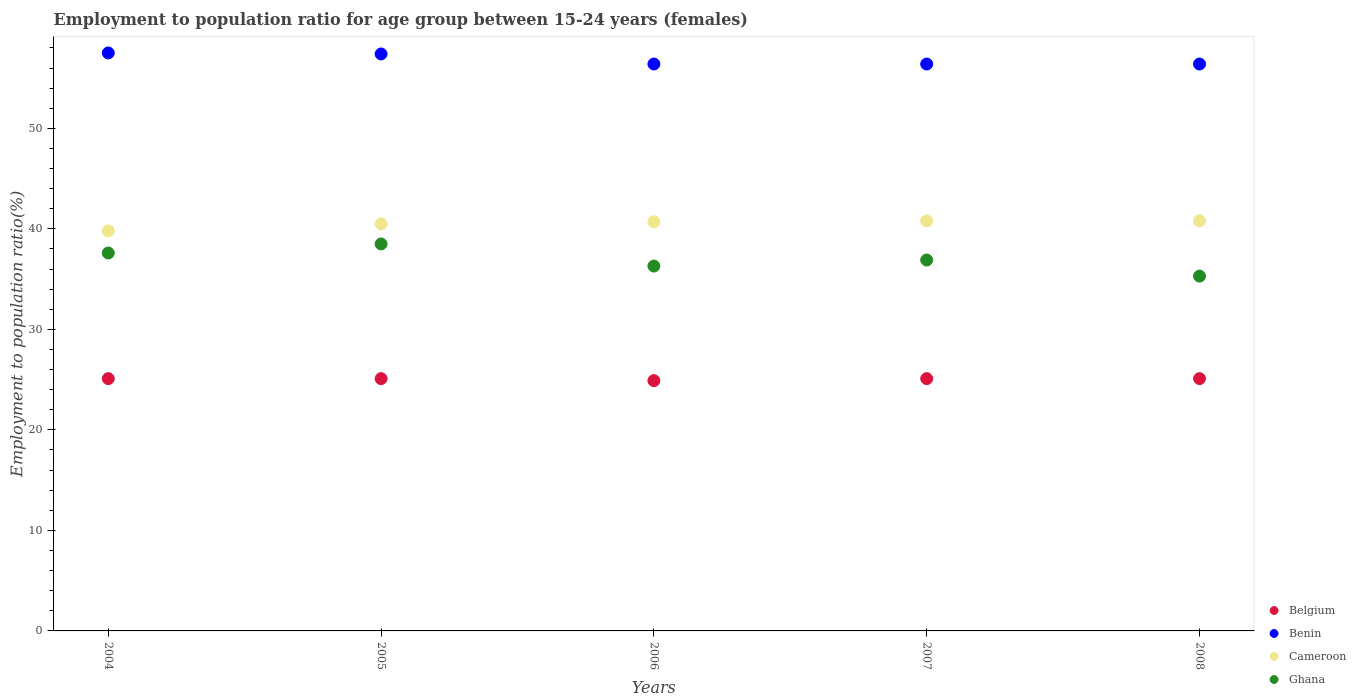Is the number of dotlines equal to the number of legend labels?
Offer a terse response. Yes. What is the employment to population ratio in Belgium in 2005?
Offer a terse response. 25.1. Across all years, what is the maximum employment to population ratio in Ghana?
Provide a short and direct response. 38.5. Across all years, what is the minimum employment to population ratio in Cameroon?
Your answer should be very brief. 39.8. In which year was the employment to population ratio in Belgium maximum?
Your response must be concise. 2004. What is the total employment to population ratio in Benin in the graph?
Your answer should be compact. 284.1. What is the difference between the employment to population ratio in Benin in 2004 and that in 2007?
Offer a very short reply. 1.1. What is the average employment to population ratio in Belgium per year?
Give a very brief answer. 25.06. In the year 2005, what is the difference between the employment to population ratio in Ghana and employment to population ratio in Belgium?
Your answer should be compact. 13.4. In how many years, is the employment to population ratio in Cameroon greater than 24 %?
Give a very brief answer. 5. What is the ratio of the employment to population ratio in Cameroon in 2004 to that in 2005?
Give a very brief answer. 0.98. Is the difference between the employment to population ratio in Ghana in 2004 and 2008 greater than the difference between the employment to population ratio in Belgium in 2004 and 2008?
Offer a terse response. Yes. What is the difference between the highest and the second highest employment to population ratio in Ghana?
Keep it short and to the point. 0.9. What is the difference between the highest and the lowest employment to population ratio in Benin?
Offer a very short reply. 1.1. Is the sum of the employment to population ratio in Ghana in 2004 and 2008 greater than the maximum employment to population ratio in Benin across all years?
Your answer should be very brief. Yes. Is it the case that in every year, the sum of the employment to population ratio in Benin and employment to population ratio in Ghana  is greater than the sum of employment to population ratio in Belgium and employment to population ratio in Cameroon?
Provide a short and direct response. Yes. Does the employment to population ratio in Cameroon monotonically increase over the years?
Ensure brevity in your answer.  No. How many years are there in the graph?
Offer a terse response. 5. What is the difference between two consecutive major ticks on the Y-axis?
Make the answer very short. 10. Does the graph contain any zero values?
Your answer should be very brief. No. Where does the legend appear in the graph?
Provide a short and direct response. Bottom right. How many legend labels are there?
Offer a very short reply. 4. How are the legend labels stacked?
Make the answer very short. Vertical. What is the title of the graph?
Your answer should be very brief. Employment to population ratio for age group between 15-24 years (females). Does "Myanmar" appear as one of the legend labels in the graph?
Make the answer very short. No. What is the Employment to population ratio(%) of Belgium in 2004?
Offer a terse response. 25.1. What is the Employment to population ratio(%) of Benin in 2004?
Make the answer very short. 57.5. What is the Employment to population ratio(%) of Cameroon in 2004?
Offer a very short reply. 39.8. What is the Employment to population ratio(%) in Ghana in 2004?
Give a very brief answer. 37.6. What is the Employment to population ratio(%) of Belgium in 2005?
Make the answer very short. 25.1. What is the Employment to population ratio(%) in Benin in 2005?
Provide a short and direct response. 57.4. What is the Employment to population ratio(%) in Cameroon in 2005?
Ensure brevity in your answer.  40.5. What is the Employment to population ratio(%) in Ghana in 2005?
Your answer should be very brief. 38.5. What is the Employment to population ratio(%) in Belgium in 2006?
Offer a very short reply. 24.9. What is the Employment to population ratio(%) in Benin in 2006?
Offer a very short reply. 56.4. What is the Employment to population ratio(%) in Cameroon in 2006?
Ensure brevity in your answer.  40.7. What is the Employment to population ratio(%) in Ghana in 2006?
Offer a terse response. 36.3. What is the Employment to population ratio(%) in Belgium in 2007?
Offer a terse response. 25.1. What is the Employment to population ratio(%) of Benin in 2007?
Your response must be concise. 56.4. What is the Employment to population ratio(%) of Cameroon in 2007?
Give a very brief answer. 40.8. What is the Employment to population ratio(%) in Ghana in 2007?
Your answer should be compact. 36.9. What is the Employment to population ratio(%) of Belgium in 2008?
Your answer should be very brief. 25.1. What is the Employment to population ratio(%) of Benin in 2008?
Your response must be concise. 56.4. What is the Employment to population ratio(%) of Cameroon in 2008?
Provide a short and direct response. 40.8. What is the Employment to population ratio(%) in Ghana in 2008?
Your answer should be compact. 35.3. Across all years, what is the maximum Employment to population ratio(%) of Belgium?
Keep it short and to the point. 25.1. Across all years, what is the maximum Employment to population ratio(%) in Benin?
Your answer should be compact. 57.5. Across all years, what is the maximum Employment to population ratio(%) of Cameroon?
Provide a succinct answer. 40.8. Across all years, what is the maximum Employment to population ratio(%) of Ghana?
Keep it short and to the point. 38.5. Across all years, what is the minimum Employment to population ratio(%) in Belgium?
Give a very brief answer. 24.9. Across all years, what is the minimum Employment to population ratio(%) in Benin?
Your answer should be compact. 56.4. Across all years, what is the minimum Employment to population ratio(%) in Cameroon?
Give a very brief answer. 39.8. Across all years, what is the minimum Employment to population ratio(%) of Ghana?
Keep it short and to the point. 35.3. What is the total Employment to population ratio(%) of Belgium in the graph?
Give a very brief answer. 125.3. What is the total Employment to population ratio(%) of Benin in the graph?
Provide a short and direct response. 284.1. What is the total Employment to population ratio(%) of Cameroon in the graph?
Give a very brief answer. 202.6. What is the total Employment to population ratio(%) in Ghana in the graph?
Offer a terse response. 184.6. What is the difference between the Employment to population ratio(%) of Belgium in 2004 and that in 2005?
Provide a succinct answer. 0. What is the difference between the Employment to population ratio(%) of Benin in 2004 and that in 2005?
Your answer should be very brief. 0.1. What is the difference between the Employment to population ratio(%) in Cameroon in 2004 and that in 2005?
Your answer should be very brief. -0.7. What is the difference between the Employment to population ratio(%) in Ghana in 2004 and that in 2005?
Provide a short and direct response. -0.9. What is the difference between the Employment to population ratio(%) of Ghana in 2004 and that in 2006?
Provide a succinct answer. 1.3. What is the difference between the Employment to population ratio(%) in Ghana in 2004 and that in 2007?
Offer a very short reply. 0.7. What is the difference between the Employment to population ratio(%) in Benin in 2004 and that in 2008?
Provide a short and direct response. 1.1. What is the difference between the Employment to population ratio(%) in Benin in 2005 and that in 2006?
Provide a succinct answer. 1. What is the difference between the Employment to population ratio(%) of Cameroon in 2005 and that in 2006?
Offer a very short reply. -0.2. What is the difference between the Employment to population ratio(%) of Cameroon in 2005 and that in 2007?
Keep it short and to the point. -0.3. What is the difference between the Employment to population ratio(%) in Ghana in 2005 and that in 2007?
Your response must be concise. 1.6. What is the difference between the Employment to population ratio(%) in Belgium in 2005 and that in 2008?
Provide a succinct answer. 0. What is the difference between the Employment to population ratio(%) in Benin in 2005 and that in 2008?
Ensure brevity in your answer.  1. What is the difference between the Employment to population ratio(%) in Cameroon in 2005 and that in 2008?
Make the answer very short. -0.3. What is the difference between the Employment to population ratio(%) in Ghana in 2005 and that in 2008?
Provide a short and direct response. 3.2. What is the difference between the Employment to population ratio(%) in Belgium in 2006 and that in 2007?
Provide a short and direct response. -0.2. What is the difference between the Employment to population ratio(%) of Ghana in 2006 and that in 2007?
Provide a short and direct response. -0.6. What is the difference between the Employment to population ratio(%) of Benin in 2006 and that in 2008?
Provide a succinct answer. 0. What is the difference between the Employment to population ratio(%) of Ghana in 2006 and that in 2008?
Give a very brief answer. 1. What is the difference between the Employment to population ratio(%) in Benin in 2007 and that in 2008?
Your answer should be very brief. 0. What is the difference between the Employment to population ratio(%) in Cameroon in 2007 and that in 2008?
Provide a short and direct response. 0. What is the difference between the Employment to population ratio(%) in Ghana in 2007 and that in 2008?
Provide a succinct answer. 1.6. What is the difference between the Employment to population ratio(%) of Belgium in 2004 and the Employment to population ratio(%) of Benin in 2005?
Make the answer very short. -32.3. What is the difference between the Employment to population ratio(%) in Belgium in 2004 and the Employment to population ratio(%) in Cameroon in 2005?
Your response must be concise. -15.4. What is the difference between the Employment to population ratio(%) of Benin in 2004 and the Employment to population ratio(%) of Cameroon in 2005?
Make the answer very short. 17. What is the difference between the Employment to population ratio(%) in Cameroon in 2004 and the Employment to population ratio(%) in Ghana in 2005?
Provide a short and direct response. 1.3. What is the difference between the Employment to population ratio(%) of Belgium in 2004 and the Employment to population ratio(%) of Benin in 2006?
Give a very brief answer. -31.3. What is the difference between the Employment to population ratio(%) of Belgium in 2004 and the Employment to population ratio(%) of Cameroon in 2006?
Your answer should be compact. -15.6. What is the difference between the Employment to population ratio(%) of Benin in 2004 and the Employment to population ratio(%) of Ghana in 2006?
Ensure brevity in your answer.  21.2. What is the difference between the Employment to population ratio(%) of Cameroon in 2004 and the Employment to population ratio(%) of Ghana in 2006?
Offer a very short reply. 3.5. What is the difference between the Employment to population ratio(%) of Belgium in 2004 and the Employment to population ratio(%) of Benin in 2007?
Your response must be concise. -31.3. What is the difference between the Employment to population ratio(%) in Belgium in 2004 and the Employment to population ratio(%) in Cameroon in 2007?
Offer a very short reply. -15.7. What is the difference between the Employment to population ratio(%) of Benin in 2004 and the Employment to population ratio(%) of Ghana in 2007?
Provide a succinct answer. 20.6. What is the difference between the Employment to population ratio(%) of Belgium in 2004 and the Employment to population ratio(%) of Benin in 2008?
Your answer should be very brief. -31.3. What is the difference between the Employment to population ratio(%) in Belgium in 2004 and the Employment to population ratio(%) in Cameroon in 2008?
Your response must be concise. -15.7. What is the difference between the Employment to population ratio(%) in Benin in 2004 and the Employment to population ratio(%) in Cameroon in 2008?
Your answer should be very brief. 16.7. What is the difference between the Employment to population ratio(%) in Belgium in 2005 and the Employment to population ratio(%) in Benin in 2006?
Provide a succinct answer. -31.3. What is the difference between the Employment to population ratio(%) in Belgium in 2005 and the Employment to population ratio(%) in Cameroon in 2006?
Offer a terse response. -15.6. What is the difference between the Employment to population ratio(%) in Benin in 2005 and the Employment to population ratio(%) in Ghana in 2006?
Your answer should be compact. 21.1. What is the difference between the Employment to population ratio(%) of Cameroon in 2005 and the Employment to population ratio(%) of Ghana in 2006?
Offer a terse response. 4.2. What is the difference between the Employment to population ratio(%) of Belgium in 2005 and the Employment to population ratio(%) of Benin in 2007?
Make the answer very short. -31.3. What is the difference between the Employment to population ratio(%) of Belgium in 2005 and the Employment to population ratio(%) of Cameroon in 2007?
Provide a short and direct response. -15.7. What is the difference between the Employment to population ratio(%) in Benin in 2005 and the Employment to population ratio(%) in Cameroon in 2007?
Ensure brevity in your answer.  16.6. What is the difference between the Employment to population ratio(%) of Benin in 2005 and the Employment to population ratio(%) of Ghana in 2007?
Your answer should be compact. 20.5. What is the difference between the Employment to population ratio(%) in Belgium in 2005 and the Employment to population ratio(%) in Benin in 2008?
Your answer should be very brief. -31.3. What is the difference between the Employment to population ratio(%) in Belgium in 2005 and the Employment to population ratio(%) in Cameroon in 2008?
Your answer should be compact. -15.7. What is the difference between the Employment to population ratio(%) of Benin in 2005 and the Employment to population ratio(%) of Cameroon in 2008?
Give a very brief answer. 16.6. What is the difference between the Employment to population ratio(%) in Benin in 2005 and the Employment to population ratio(%) in Ghana in 2008?
Offer a very short reply. 22.1. What is the difference between the Employment to population ratio(%) of Belgium in 2006 and the Employment to population ratio(%) of Benin in 2007?
Offer a terse response. -31.5. What is the difference between the Employment to population ratio(%) in Belgium in 2006 and the Employment to population ratio(%) in Cameroon in 2007?
Give a very brief answer. -15.9. What is the difference between the Employment to population ratio(%) in Cameroon in 2006 and the Employment to population ratio(%) in Ghana in 2007?
Offer a terse response. 3.8. What is the difference between the Employment to population ratio(%) of Belgium in 2006 and the Employment to population ratio(%) of Benin in 2008?
Keep it short and to the point. -31.5. What is the difference between the Employment to population ratio(%) of Belgium in 2006 and the Employment to population ratio(%) of Cameroon in 2008?
Make the answer very short. -15.9. What is the difference between the Employment to population ratio(%) in Benin in 2006 and the Employment to population ratio(%) in Cameroon in 2008?
Offer a very short reply. 15.6. What is the difference between the Employment to population ratio(%) in Benin in 2006 and the Employment to population ratio(%) in Ghana in 2008?
Make the answer very short. 21.1. What is the difference between the Employment to population ratio(%) in Belgium in 2007 and the Employment to population ratio(%) in Benin in 2008?
Your answer should be compact. -31.3. What is the difference between the Employment to population ratio(%) of Belgium in 2007 and the Employment to population ratio(%) of Cameroon in 2008?
Ensure brevity in your answer.  -15.7. What is the difference between the Employment to population ratio(%) of Belgium in 2007 and the Employment to population ratio(%) of Ghana in 2008?
Ensure brevity in your answer.  -10.2. What is the difference between the Employment to population ratio(%) of Benin in 2007 and the Employment to population ratio(%) of Ghana in 2008?
Your response must be concise. 21.1. What is the average Employment to population ratio(%) of Belgium per year?
Offer a terse response. 25.06. What is the average Employment to population ratio(%) of Benin per year?
Make the answer very short. 56.82. What is the average Employment to population ratio(%) of Cameroon per year?
Your answer should be compact. 40.52. What is the average Employment to population ratio(%) of Ghana per year?
Your answer should be compact. 36.92. In the year 2004, what is the difference between the Employment to population ratio(%) of Belgium and Employment to population ratio(%) of Benin?
Make the answer very short. -32.4. In the year 2004, what is the difference between the Employment to population ratio(%) in Belgium and Employment to population ratio(%) in Cameroon?
Your response must be concise. -14.7. In the year 2004, what is the difference between the Employment to population ratio(%) in Benin and Employment to population ratio(%) in Ghana?
Your response must be concise. 19.9. In the year 2005, what is the difference between the Employment to population ratio(%) in Belgium and Employment to population ratio(%) in Benin?
Ensure brevity in your answer.  -32.3. In the year 2005, what is the difference between the Employment to population ratio(%) of Belgium and Employment to population ratio(%) of Cameroon?
Your answer should be very brief. -15.4. In the year 2005, what is the difference between the Employment to population ratio(%) in Benin and Employment to population ratio(%) in Ghana?
Your response must be concise. 18.9. In the year 2006, what is the difference between the Employment to population ratio(%) of Belgium and Employment to population ratio(%) of Benin?
Your response must be concise. -31.5. In the year 2006, what is the difference between the Employment to population ratio(%) in Belgium and Employment to population ratio(%) in Cameroon?
Give a very brief answer. -15.8. In the year 2006, what is the difference between the Employment to population ratio(%) of Belgium and Employment to population ratio(%) of Ghana?
Your answer should be very brief. -11.4. In the year 2006, what is the difference between the Employment to population ratio(%) of Benin and Employment to population ratio(%) of Ghana?
Provide a succinct answer. 20.1. In the year 2006, what is the difference between the Employment to population ratio(%) of Cameroon and Employment to population ratio(%) of Ghana?
Offer a terse response. 4.4. In the year 2007, what is the difference between the Employment to population ratio(%) in Belgium and Employment to population ratio(%) in Benin?
Offer a very short reply. -31.3. In the year 2007, what is the difference between the Employment to population ratio(%) of Belgium and Employment to population ratio(%) of Cameroon?
Make the answer very short. -15.7. In the year 2007, what is the difference between the Employment to population ratio(%) of Belgium and Employment to population ratio(%) of Ghana?
Give a very brief answer. -11.8. In the year 2007, what is the difference between the Employment to population ratio(%) in Benin and Employment to population ratio(%) in Ghana?
Your response must be concise. 19.5. In the year 2008, what is the difference between the Employment to population ratio(%) of Belgium and Employment to population ratio(%) of Benin?
Ensure brevity in your answer.  -31.3. In the year 2008, what is the difference between the Employment to population ratio(%) of Belgium and Employment to population ratio(%) of Cameroon?
Provide a succinct answer. -15.7. In the year 2008, what is the difference between the Employment to population ratio(%) of Benin and Employment to population ratio(%) of Cameroon?
Keep it short and to the point. 15.6. In the year 2008, what is the difference between the Employment to population ratio(%) of Benin and Employment to population ratio(%) of Ghana?
Provide a short and direct response. 21.1. In the year 2008, what is the difference between the Employment to population ratio(%) in Cameroon and Employment to population ratio(%) in Ghana?
Make the answer very short. 5.5. What is the ratio of the Employment to population ratio(%) in Cameroon in 2004 to that in 2005?
Offer a terse response. 0.98. What is the ratio of the Employment to population ratio(%) in Ghana in 2004 to that in 2005?
Keep it short and to the point. 0.98. What is the ratio of the Employment to population ratio(%) of Benin in 2004 to that in 2006?
Offer a terse response. 1.02. What is the ratio of the Employment to population ratio(%) of Cameroon in 2004 to that in 2006?
Make the answer very short. 0.98. What is the ratio of the Employment to population ratio(%) of Ghana in 2004 to that in 2006?
Your answer should be compact. 1.04. What is the ratio of the Employment to population ratio(%) of Benin in 2004 to that in 2007?
Give a very brief answer. 1.02. What is the ratio of the Employment to population ratio(%) of Cameroon in 2004 to that in 2007?
Give a very brief answer. 0.98. What is the ratio of the Employment to population ratio(%) in Ghana in 2004 to that in 2007?
Provide a succinct answer. 1.02. What is the ratio of the Employment to population ratio(%) in Benin in 2004 to that in 2008?
Give a very brief answer. 1.02. What is the ratio of the Employment to population ratio(%) of Cameroon in 2004 to that in 2008?
Ensure brevity in your answer.  0.98. What is the ratio of the Employment to population ratio(%) in Ghana in 2004 to that in 2008?
Your response must be concise. 1.07. What is the ratio of the Employment to population ratio(%) of Benin in 2005 to that in 2006?
Offer a terse response. 1.02. What is the ratio of the Employment to population ratio(%) in Ghana in 2005 to that in 2006?
Offer a terse response. 1.06. What is the ratio of the Employment to population ratio(%) in Benin in 2005 to that in 2007?
Your answer should be compact. 1.02. What is the ratio of the Employment to population ratio(%) in Ghana in 2005 to that in 2007?
Make the answer very short. 1.04. What is the ratio of the Employment to population ratio(%) of Belgium in 2005 to that in 2008?
Your answer should be very brief. 1. What is the ratio of the Employment to population ratio(%) in Benin in 2005 to that in 2008?
Give a very brief answer. 1.02. What is the ratio of the Employment to population ratio(%) of Ghana in 2005 to that in 2008?
Your answer should be compact. 1.09. What is the ratio of the Employment to population ratio(%) of Belgium in 2006 to that in 2007?
Offer a very short reply. 0.99. What is the ratio of the Employment to population ratio(%) in Benin in 2006 to that in 2007?
Offer a terse response. 1. What is the ratio of the Employment to population ratio(%) of Ghana in 2006 to that in 2007?
Provide a succinct answer. 0.98. What is the ratio of the Employment to population ratio(%) in Cameroon in 2006 to that in 2008?
Make the answer very short. 1. What is the ratio of the Employment to population ratio(%) of Ghana in 2006 to that in 2008?
Provide a succinct answer. 1.03. What is the ratio of the Employment to population ratio(%) in Belgium in 2007 to that in 2008?
Your answer should be compact. 1. What is the ratio of the Employment to population ratio(%) in Benin in 2007 to that in 2008?
Your answer should be very brief. 1. What is the ratio of the Employment to population ratio(%) in Cameroon in 2007 to that in 2008?
Your response must be concise. 1. What is the ratio of the Employment to population ratio(%) in Ghana in 2007 to that in 2008?
Keep it short and to the point. 1.05. What is the difference between the highest and the second highest Employment to population ratio(%) of Benin?
Your answer should be very brief. 0.1. What is the difference between the highest and the second highest Employment to population ratio(%) in Cameroon?
Keep it short and to the point. 0. What is the difference between the highest and the lowest Employment to population ratio(%) in Belgium?
Give a very brief answer. 0.2. What is the difference between the highest and the lowest Employment to population ratio(%) of Benin?
Offer a terse response. 1.1. 